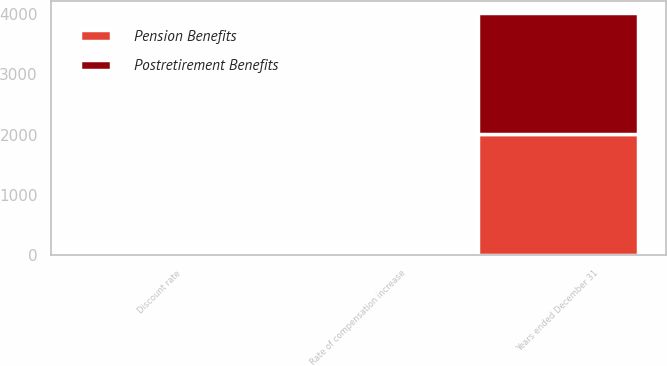Convert chart to OTSL. <chart><loc_0><loc_0><loc_500><loc_500><stacked_bar_chart><ecel><fcel>Years ended December 31<fcel>Discount rate<fcel>Rate of compensation increase<nl><fcel>Postretirement Benefits<fcel>2004<fcel>6.25<fcel>4<nl><fcel>Pension Benefits<fcel>2004<fcel>6.25<fcel>4<nl></chart> 